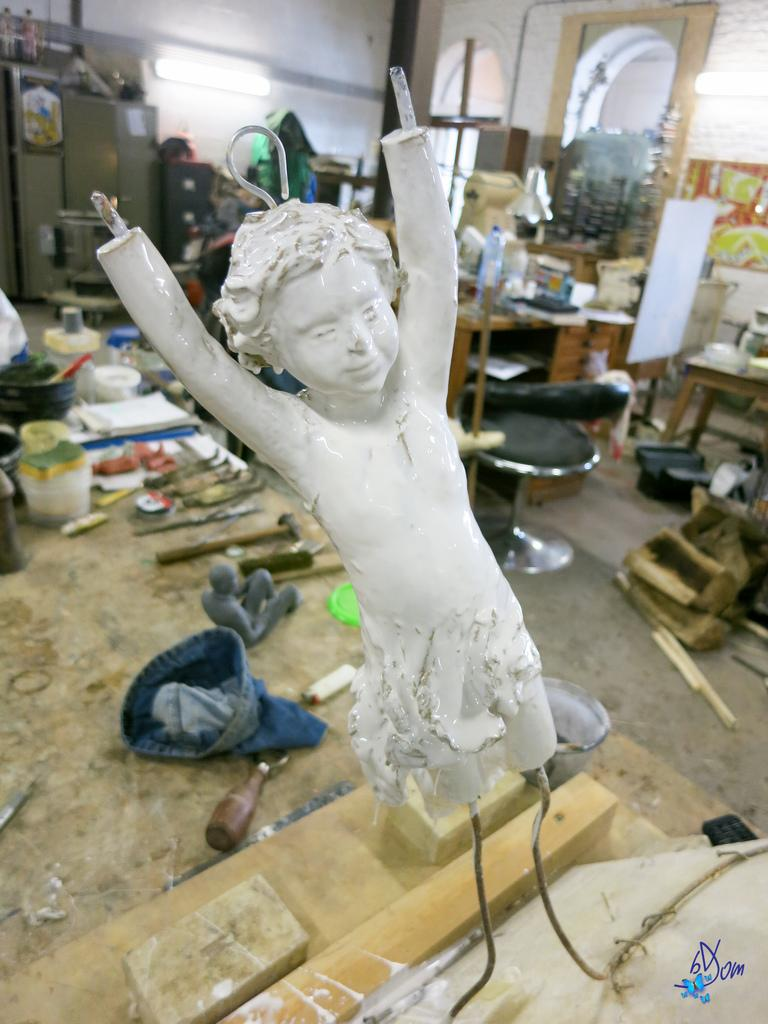What is the main piece of furniture in the image? There is a table in the image. What is placed on the table? There is a sculpture, a cap, a toy, and books on the table. Are there any other items on the table? Yes, there are other things on the table. What can be seen in the background of the image? There is a wall and another table visible in the background. What is visible on the floor? The floor is visible in the image. What type of seating is present in the image? There are chairs in the image. What type of railway can be seen in the image? There is no railway present in the image. How many birds are sitting on the table in the image? There are no birds present in the image. 